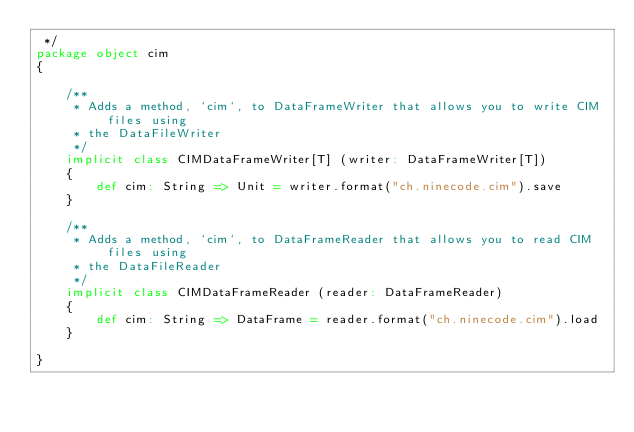<code> <loc_0><loc_0><loc_500><loc_500><_Scala_> */
package object cim
{

    /**
     * Adds a method, `cim`, to DataFrameWriter that allows you to write CIM files using
     * the DataFileWriter
     */
    implicit class CIMDataFrameWriter[T] (writer: DataFrameWriter[T])
    {
        def cim: String => Unit = writer.format("ch.ninecode.cim").save
    }

    /**
     * Adds a method, `cim`, to DataFrameReader that allows you to read CIM files using
     * the DataFileReader
     */
    implicit class CIMDataFrameReader (reader: DataFrameReader)
    {
        def cim: String => DataFrame = reader.format("ch.ninecode.cim").load
    }

}
</code> 